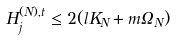Convert formula to latex. <formula><loc_0><loc_0><loc_500><loc_500>H ^ { ( N ) , t } _ { j } \leq 2 ( l K _ { N } + m \Omega _ { N } )</formula> 